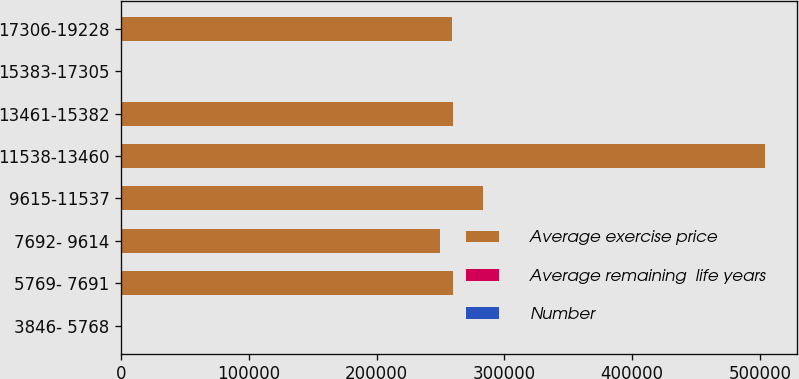Convert chart. <chart><loc_0><loc_0><loc_500><loc_500><stacked_bar_chart><ecel><fcel>3846- 5768<fcel>5769- 7691<fcel>7692- 9614<fcel>9615-11537<fcel>11538-13460<fcel>13461-15382<fcel>15383-17305<fcel>17306-19228<nl><fcel>Average exercise price<fcel>104.165<fcel>259460<fcel>249281<fcel>283069<fcel>503778<fcel>259370<fcel>104.165<fcel>258625<nl><fcel>Average remaining  life years<fcel>53.28<fcel>72.55<fcel>93.34<fcel>114.99<fcel>130.72<fcel>144.19<fcel>167.8<fcel>179.42<nl><fcel>Number<fcel>1.5<fcel>4.2<fcel>5<fcel>6<fcel>7<fcel>7.7<fcel>8.8<fcel>9.5<nl></chart> 